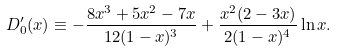Convert formula to latex. <formula><loc_0><loc_0><loc_500><loc_500>D ^ { \prime } _ { 0 } ( x ) \equiv - \frac { 8 x ^ { 3 } + 5 x ^ { 2 } - 7 x } { 1 2 ( 1 - x ) ^ { 3 } } + \frac { x ^ { 2 } ( 2 - 3 x ) } { 2 ( 1 - x ) ^ { 4 } } \ln x .</formula> 